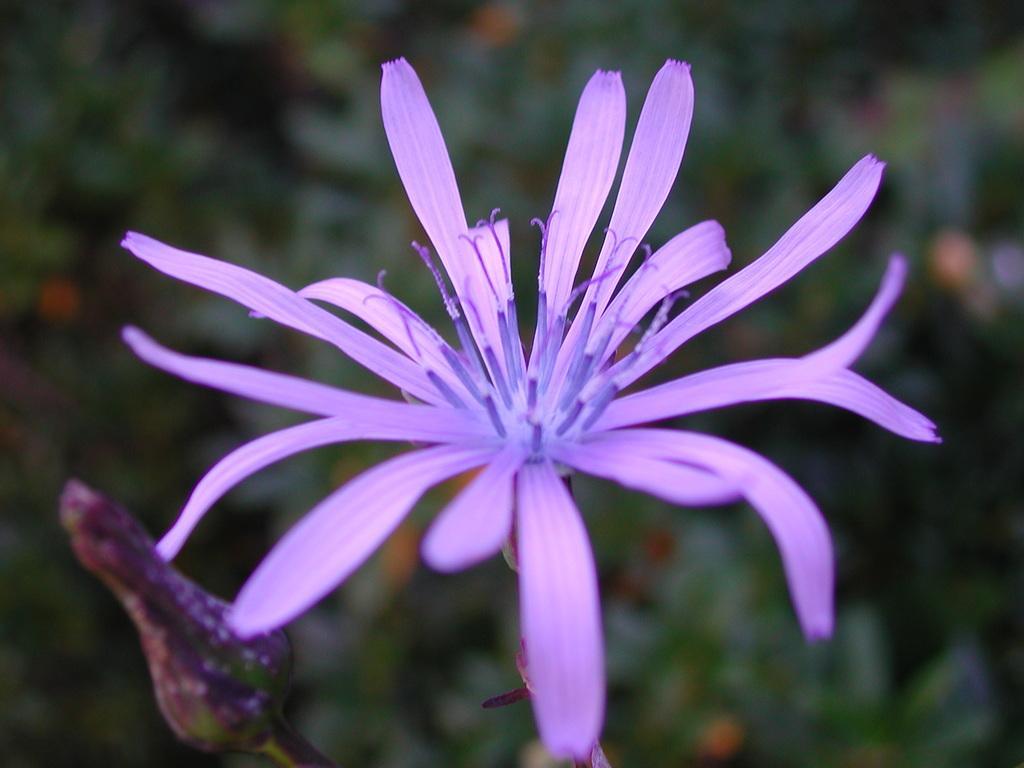Can you describe this image briefly? In the image there is a purple flower and a flower bud, the background of the flower is blue. 